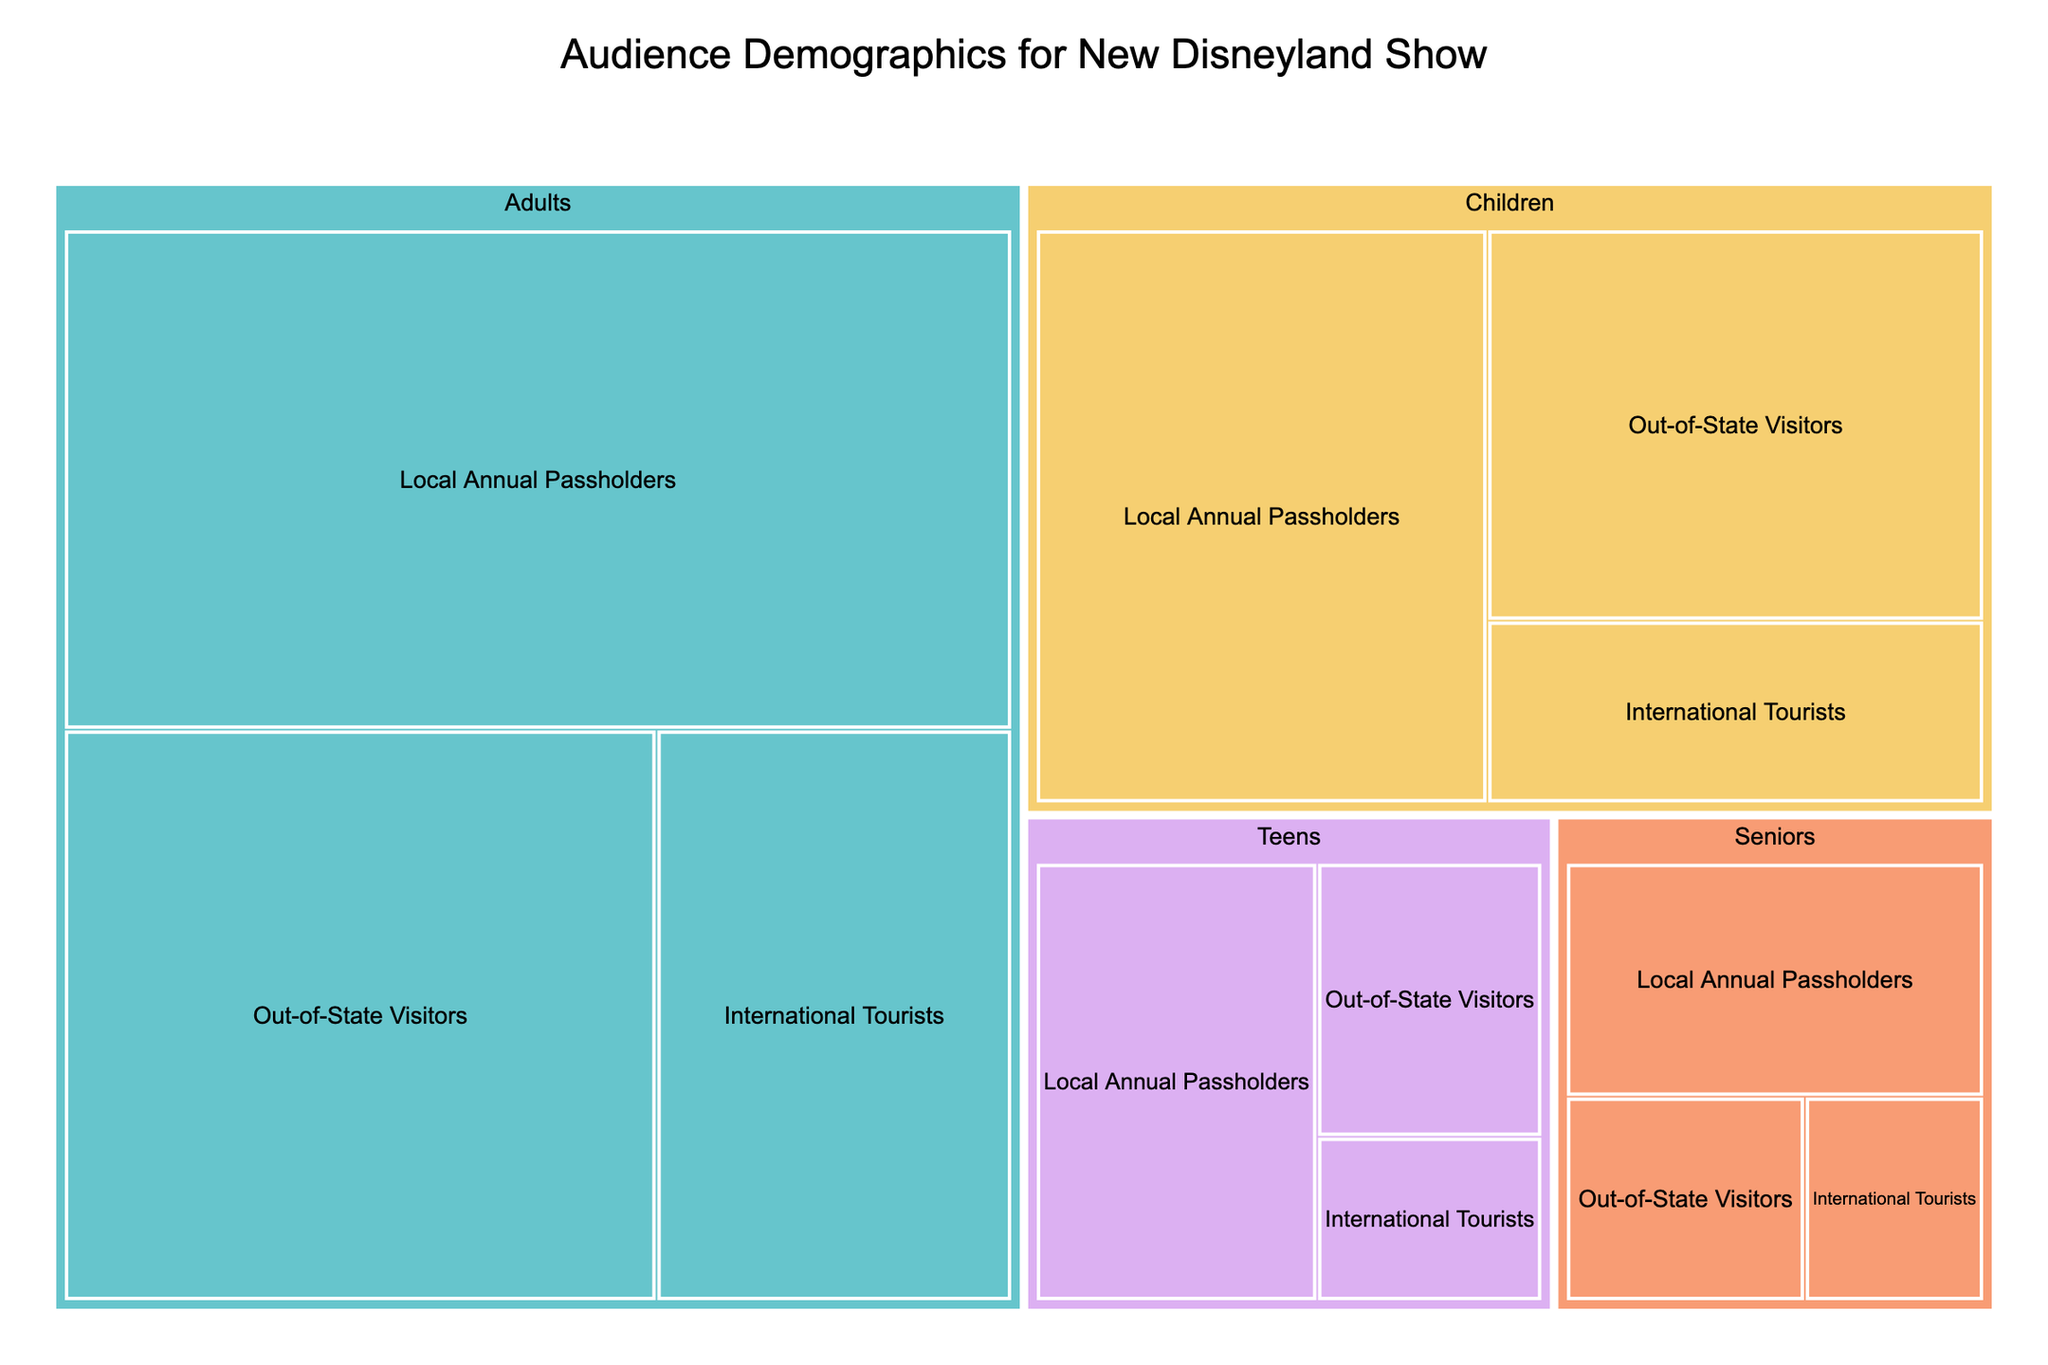What's the title of the treemap? The title is usually displayed at the top of the treemap and summarizes the content of the plot.
Answer: Audience Demographics for New Disneyland Show Which age group has the largest representation of local annual passholders? By examining the largest segments for local annual passholders, it's clear to see which age group occupies the most space.
Answer: Adults How many teens are local annual passholders? Locate the section for Teens in the treemap and find the subcategory labeled "Local Annual Passholders" to sum the corresponding value.
Answer: 10 What is the total number of children visiting the show? Add the values for all subcategories under the Children category: Local Annual Passholders (20), Out-of-State Visitors (15), and International Tourists (7). 20 + 15 + 7 = 42
Answer: 42 Which visitor type has the least representation among seniors? Look at the Senior category and compare the sizes of the subcategories; the smallest one corresponds to the least represented visitor type.
Answer: International Tourists What is the difference in the number of local annual passholders between adults and children? Subtract the number of Local Annual Passholders in the Children category from the number of Local Annual Passholders in the Adults category: 35 (Adults) - 20 (Children) = 15
Answer: 15 Among international tourists, which age group has the highest representation? Identify the subcategories under International Tourists across each age group, and compare their values.
Answer: Adults How does the number of international tourists compare between adults and children? The number of international tourists is 15 for Adults and 7 for Children. Comparing these values (15 vs. 7), Adults have a higher number of international tourists.
Answer: Adults have more international tourists What percentage of local annual passholders are children, considering all local annual passholder groups? Sum the total number of Local Annual Passholders: Adults (35) + Teens (10) + Children (20) + Seniors (8) = 73. The percentage for children is then (20/73) * 100 ≈ 27.4%
Answer: ≈ 27.4% Which is the largest segment in the entire treemap in terms of audience value? Determine which segment, considering all categories and subcategories, occupies the most space, indicating the highest audience value.
Answer: Adults Local Annual Passholders 